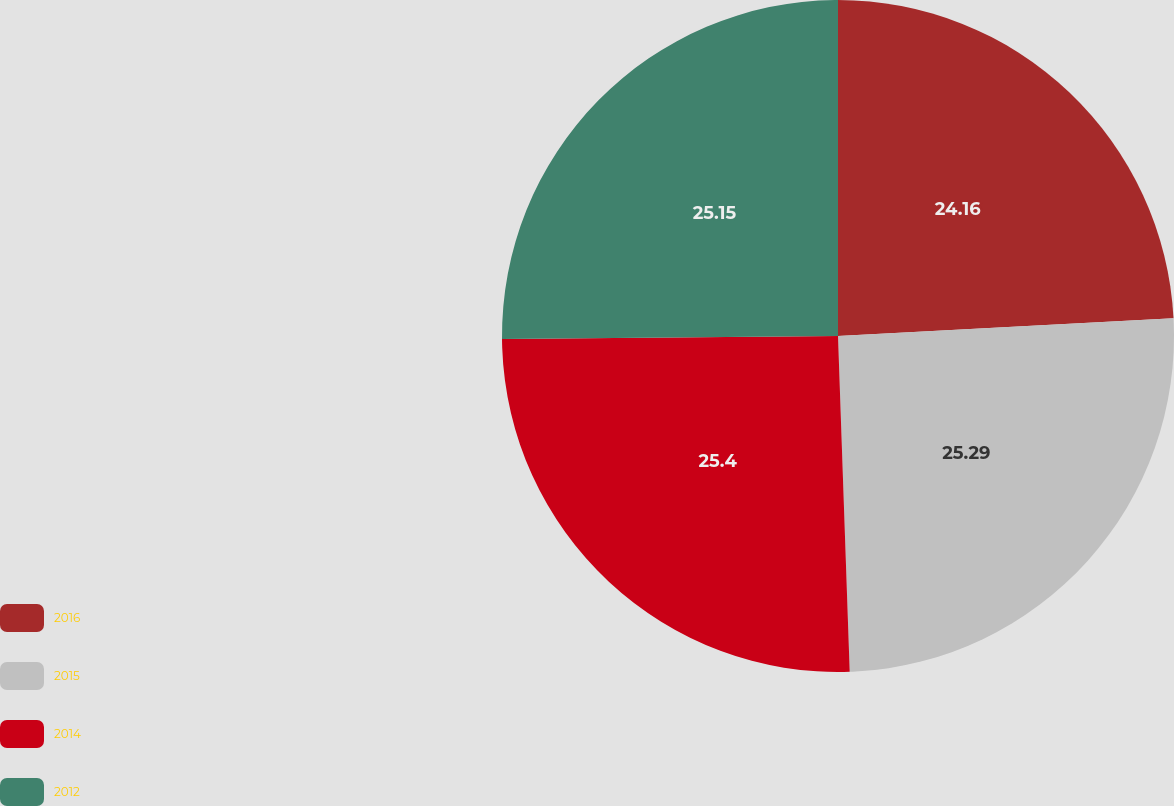<chart> <loc_0><loc_0><loc_500><loc_500><pie_chart><fcel>2016<fcel>2015<fcel>2014<fcel>2012<nl><fcel>24.16%<fcel>25.29%<fcel>25.41%<fcel>25.15%<nl></chart> 